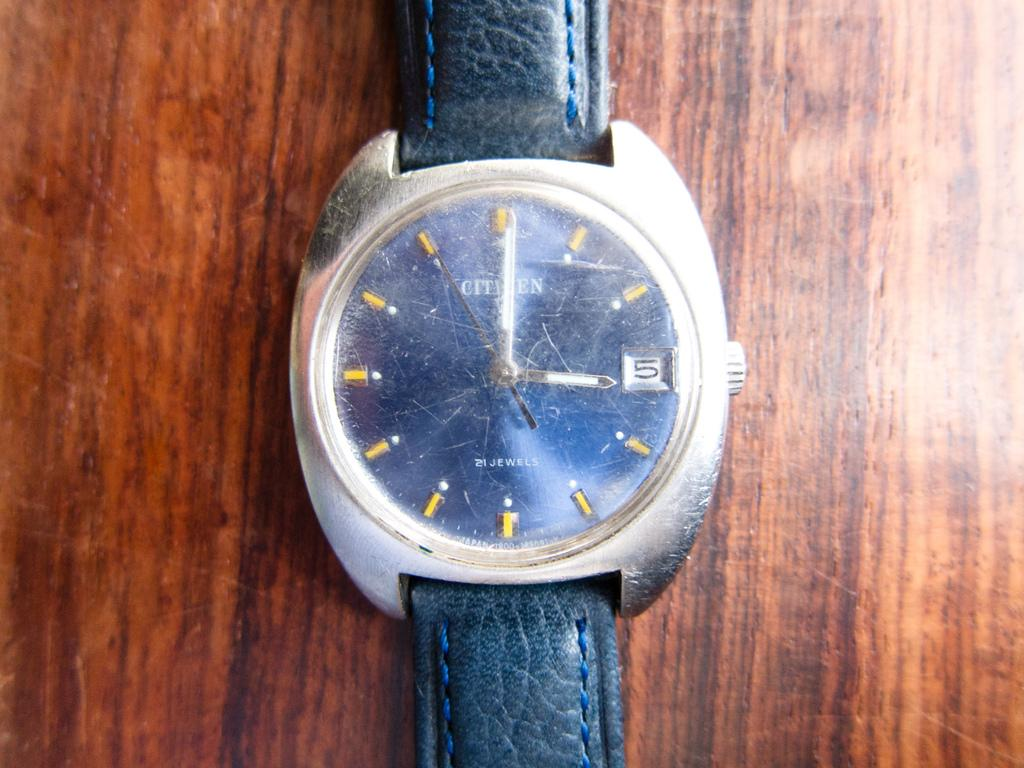<image>
Present a compact description of the photo's key features. Black and silver watch with a face that says CITIZEN on it. 